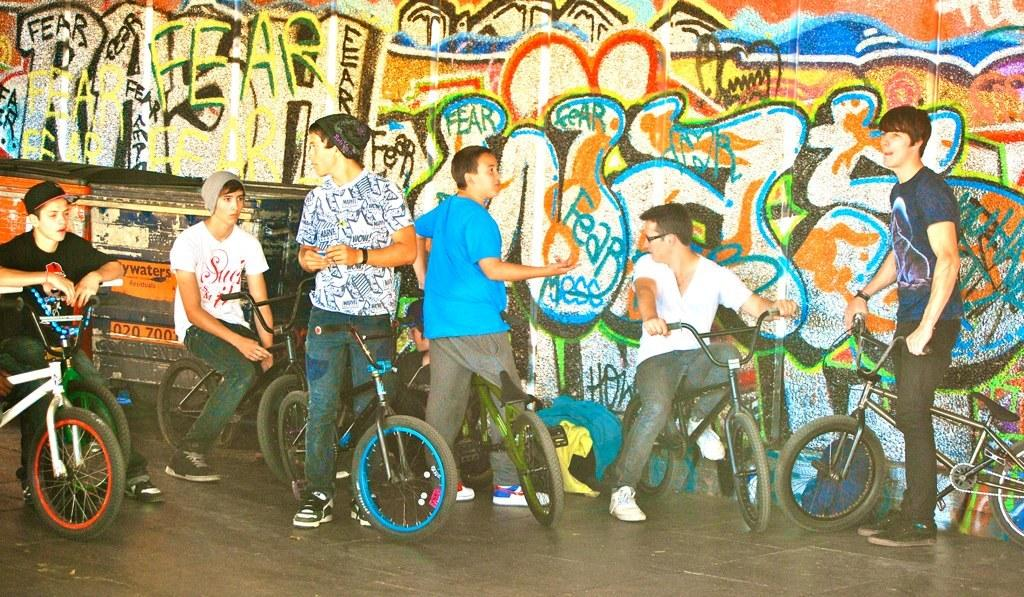How many people are in the image? There is a group of people in the image. What are some of the people doing in the image? Some of the people are sitting on a cycle, while others are standing. What can be seen in the background of the image? There is a wall in the background of the image. What is on the wall in the image? There is graffiti on the wall. How many chickens are present in the image? There are no chickens present in the image. What type of spiders can be seen crawling on the graffiti in the image? There are no spiders visible in the image, and the graffiti does not depict any spiders. 